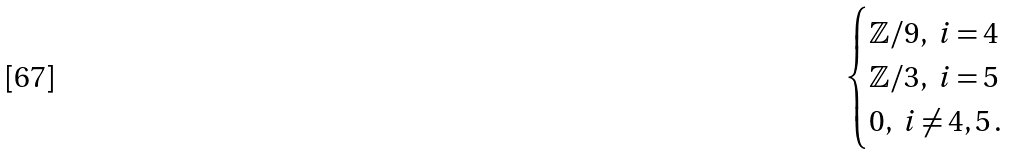<formula> <loc_0><loc_0><loc_500><loc_500>\begin{cases} \mathbb { Z } / 9 , \ i = 4 \\ \mathbb { Z } / 3 , \ i = 5 \\ 0 , \ i \neq 4 , 5 \, . \end{cases}</formula> 